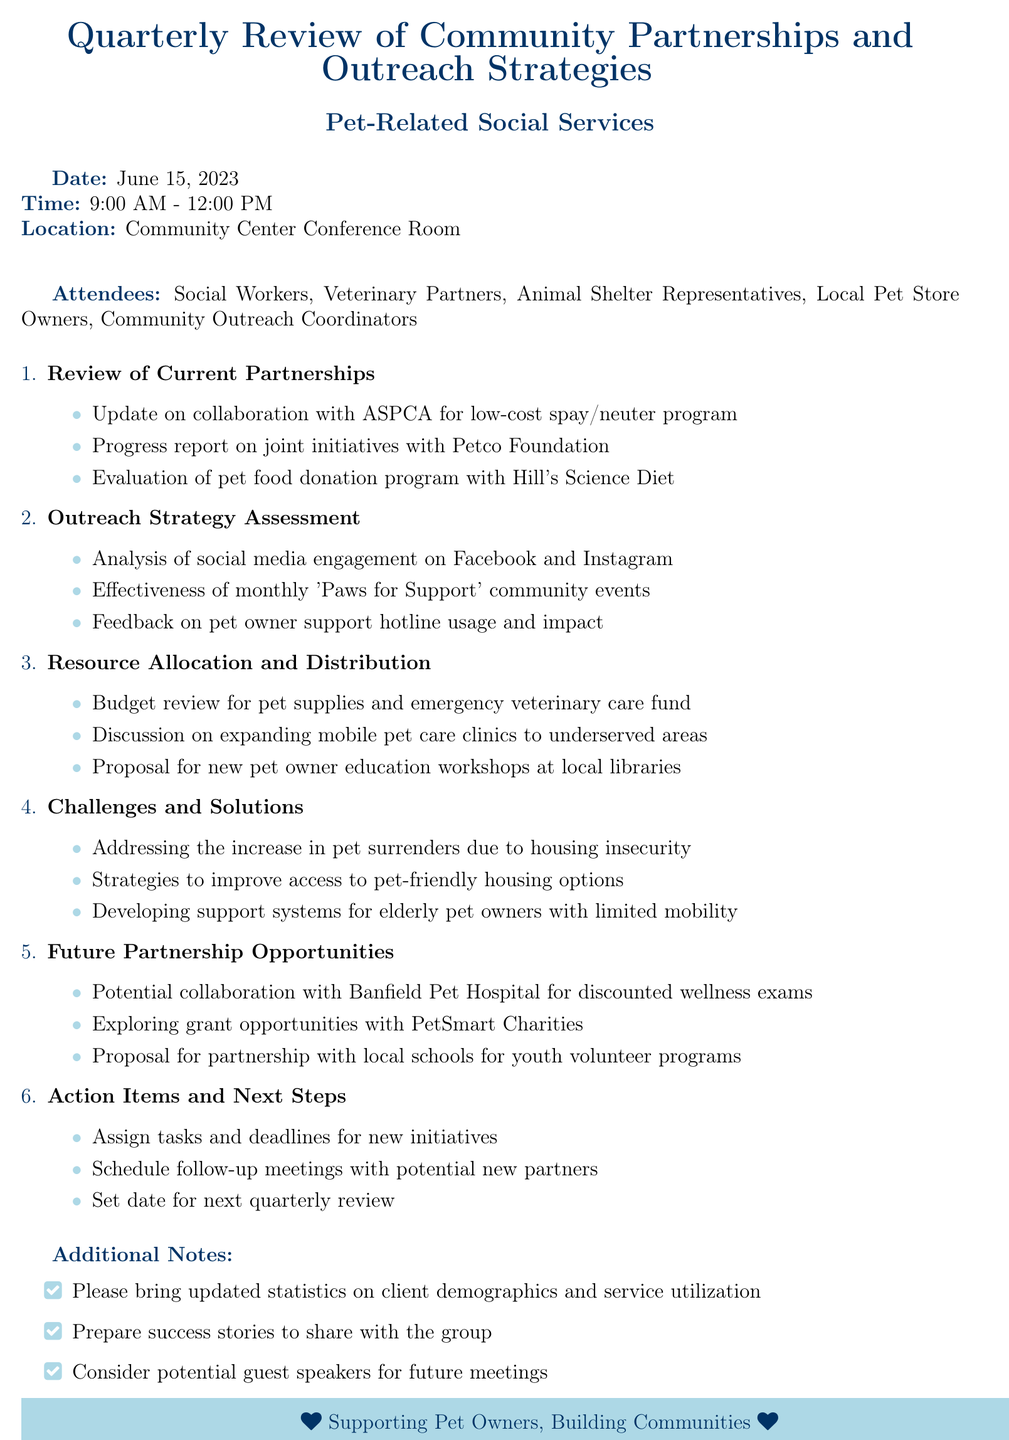What is the date of the meeting? The date of the meeting is explicitly stated in the document as June 15, 2023.
Answer: June 15, 2023 What is the location of the meeting? The location of the meeting is mentioned in the document as the Community Center Conference Room.
Answer: Community Center Conference Room How many attendees are listed? The number of attendees can be found by counting the roles listed in the document. There are five roles mentioned.
Answer: Five What is one of the specific outreach strategies being assessed? One specific outreach strategy mentioned in the document for assessment is the effectiveness of monthly 'Paws for Support' community events.
Answer: Effectiveness of monthly 'Paws for Support' community events What issue is addressed under the challenges section? The document lists addressing the increase in pet surrenders due to housing insecurity as a challenge, which requires attention during the meeting.
Answer: Increase in pet surrenders due to housing insecurity What type of partnership opportunity is suggested with Banfield Pet Hospital? The document proposes a collaboration with Banfield Pet Hospital for discounted wellness exams.
Answer: Discounted wellness exams How are action items determined in the meeting? The action items entail assigning tasks and deadlines for new initiatives, as described in the document.
Answer: Assign tasks and deadlines for new initiatives Why should attendees bring updated statistics? Attendees are asked to bring updated statistics on client demographics and service utilization for a comprehensive review.
Answer: Client demographics and service utilization 